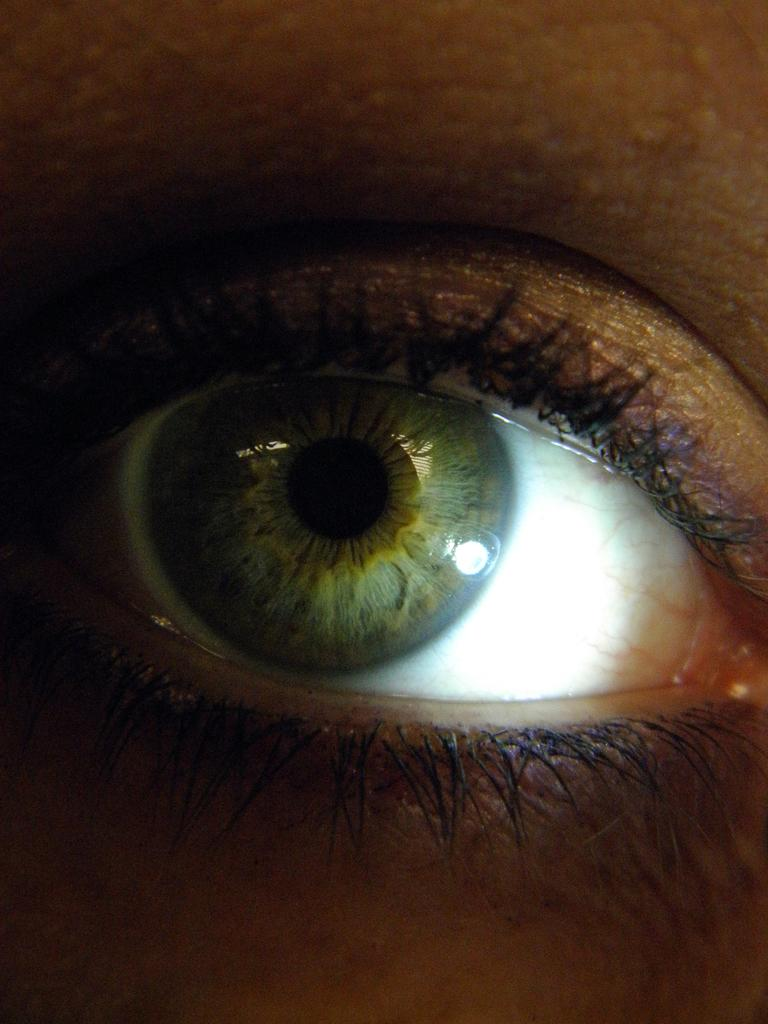What is the main subject of the image? The main subject of the image is a person's eye. Can you describe any specific features of the eye in the image? Unfortunately, the provided facts do not include any specific features of the eye. Is there any context or background information provided for the image? No, the only fact provided is that there is a person's eye in the image. What sign is the dad holding while teaching in the image? There is no sign, dad, or teaching activity present in the image; it only features a person's eye. 